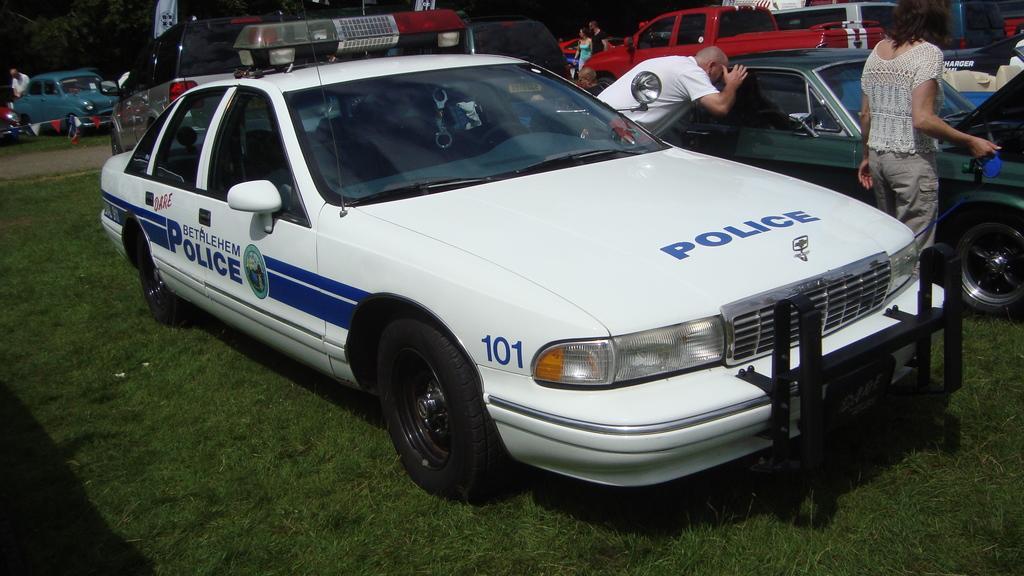In one or two sentences, can you explain what this image depicts? In this picture we can see there are vehicles and people on the grass. At the top left corner of the image, there is a tree. 